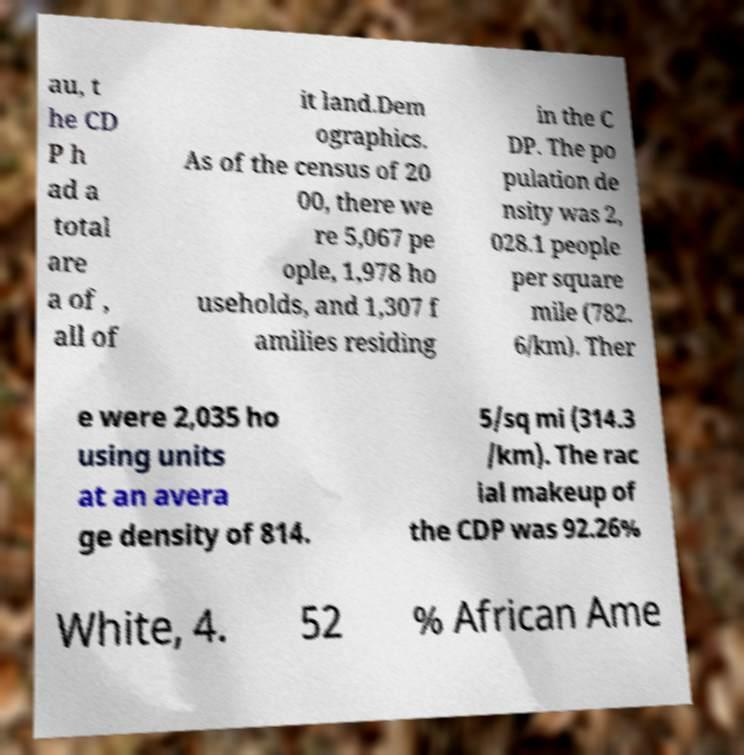Please read and relay the text visible in this image. What does it say? au, t he CD P h ad a total are a of , all of it land.Dem ographics. As of the census of 20 00, there we re 5,067 pe ople, 1,978 ho useholds, and 1,307 f amilies residing in the C DP. The po pulation de nsity was 2, 028.1 people per square mile (782. 6/km). Ther e were 2,035 ho using units at an avera ge density of 814. 5/sq mi (314.3 /km). The rac ial makeup of the CDP was 92.26% White, 4. 52 % African Ame 